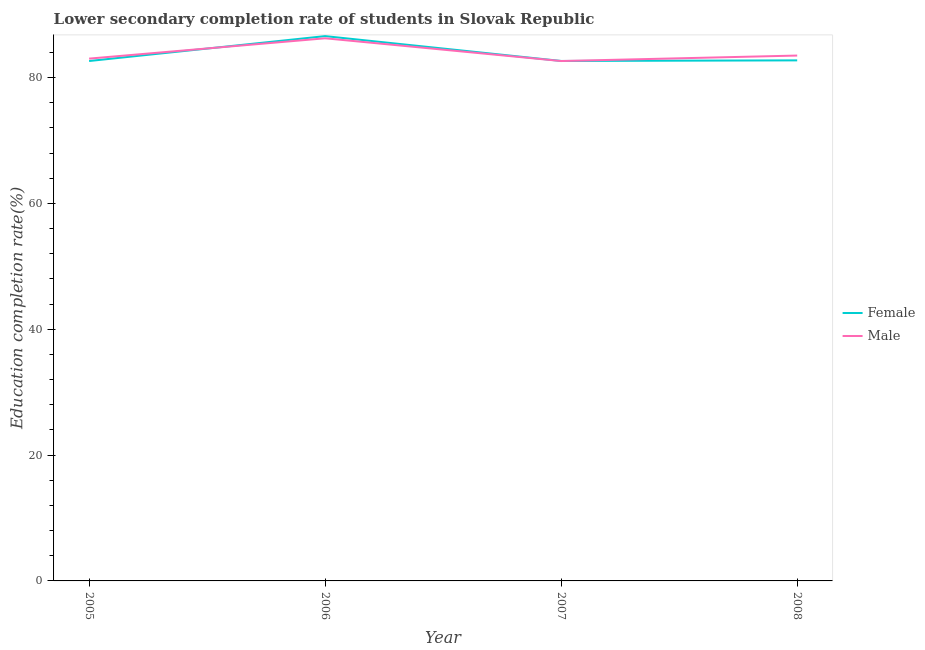How many different coloured lines are there?
Your answer should be very brief. 2. Does the line corresponding to education completion rate of female students intersect with the line corresponding to education completion rate of male students?
Ensure brevity in your answer.  Yes. Is the number of lines equal to the number of legend labels?
Keep it short and to the point. Yes. What is the education completion rate of female students in 2008?
Offer a terse response. 82.73. Across all years, what is the maximum education completion rate of female students?
Your answer should be very brief. 86.59. Across all years, what is the minimum education completion rate of male students?
Keep it short and to the point. 82.63. What is the total education completion rate of female students in the graph?
Ensure brevity in your answer.  334.58. What is the difference between the education completion rate of male students in 2007 and that in 2008?
Your answer should be very brief. -0.87. What is the difference between the education completion rate of female students in 2007 and the education completion rate of male students in 2008?
Your answer should be very brief. -0.86. What is the average education completion rate of female students per year?
Offer a terse response. 83.65. In the year 2007, what is the difference between the education completion rate of male students and education completion rate of female students?
Keep it short and to the point. -0.01. What is the ratio of the education completion rate of male students in 2005 to that in 2007?
Offer a terse response. 1. What is the difference between the highest and the second highest education completion rate of female students?
Your response must be concise. 3.86. What is the difference between the highest and the lowest education completion rate of female students?
Ensure brevity in your answer.  3.96. In how many years, is the education completion rate of male students greater than the average education completion rate of male students taken over all years?
Keep it short and to the point. 1. Is the sum of the education completion rate of female students in 2005 and 2007 greater than the maximum education completion rate of male students across all years?
Keep it short and to the point. Yes. Is the education completion rate of female students strictly greater than the education completion rate of male students over the years?
Offer a terse response. No. Are the values on the major ticks of Y-axis written in scientific E-notation?
Ensure brevity in your answer.  No. Does the graph contain any zero values?
Your response must be concise. No. How many legend labels are there?
Keep it short and to the point. 2. How are the legend labels stacked?
Provide a succinct answer. Vertical. What is the title of the graph?
Offer a very short reply. Lower secondary completion rate of students in Slovak Republic. Does "Nitrous oxide emissions" appear as one of the legend labels in the graph?
Keep it short and to the point. No. What is the label or title of the X-axis?
Offer a very short reply. Year. What is the label or title of the Y-axis?
Give a very brief answer. Education completion rate(%). What is the Education completion rate(%) in Female in 2005?
Provide a succinct answer. 82.63. What is the Education completion rate(%) of Male in 2005?
Give a very brief answer. 83.01. What is the Education completion rate(%) of Female in 2006?
Your answer should be very brief. 86.59. What is the Education completion rate(%) of Male in 2006?
Your answer should be compact. 86.24. What is the Education completion rate(%) in Female in 2007?
Your answer should be compact. 82.64. What is the Education completion rate(%) of Male in 2007?
Offer a very short reply. 82.63. What is the Education completion rate(%) of Female in 2008?
Offer a very short reply. 82.73. What is the Education completion rate(%) in Male in 2008?
Your answer should be compact. 83.5. Across all years, what is the maximum Education completion rate(%) of Female?
Give a very brief answer. 86.59. Across all years, what is the maximum Education completion rate(%) in Male?
Provide a succinct answer. 86.24. Across all years, what is the minimum Education completion rate(%) in Female?
Your answer should be very brief. 82.63. Across all years, what is the minimum Education completion rate(%) in Male?
Provide a succinct answer. 82.63. What is the total Education completion rate(%) of Female in the graph?
Provide a short and direct response. 334.58. What is the total Education completion rate(%) in Male in the graph?
Your answer should be compact. 335.37. What is the difference between the Education completion rate(%) in Female in 2005 and that in 2006?
Your answer should be very brief. -3.96. What is the difference between the Education completion rate(%) of Male in 2005 and that in 2006?
Your answer should be very brief. -3.23. What is the difference between the Education completion rate(%) in Female in 2005 and that in 2007?
Your answer should be very brief. -0.01. What is the difference between the Education completion rate(%) of Male in 2005 and that in 2007?
Keep it short and to the point. 0.38. What is the difference between the Education completion rate(%) in Female in 2005 and that in 2008?
Your answer should be compact. -0.1. What is the difference between the Education completion rate(%) in Male in 2005 and that in 2008?
Provide a succinct answer. -0.49. What is the difference between the Education completion rate(%) of Female in 2006 and that in 2007?
Ensure brevity in your answer.  3.95. What is the difference between the Education completion rate(%) in Male in 2006 and that in 2007?
Ensure brevity in your answer.  3.61. What is the difference between the Education completion rate(%) in Female in 2006 and that in 2008?
Your answer should be compact. 3.86. What is the difference between the Education completion rate(%) of Male in 2006 and that in 2008?
Offer a terse response. 2.74. What is the difference between the Education completion rate(%) of Female in 2007 and that in 2008?
Provide a short and direct response. -0.09. What is the difference between the Education completion rate(%) of Male in 2007 and that in 2008?
Offer a very short reply. -0.87. What is the difference between the Education completion rate(%) in Female in 2005 and the Education completion rate(%) in Male in 2006?
Your answer should be compact. -3.61. What is the difference between the Education completion rate(%) of Female in 2005 and the Education completion rate(%) of Male in 2007?
Your answer should be very brief. 0. What is the difference between the Education completion rate(%) of Female in 2005 and the Education completion rate(%) of Male in 2008?
Provide a succinct answer. -0.87. What is the difference between the Education completion rate(%) in Female in 2006 and the Education completion rate(%) in Male in 2007?
Provide a short and direct response. 3.96. What is the difference between the Education completion rate(%) of Female in 2006 and the Education completion rate(%) of Male in 2008?
Provide a succinct answer. 3.09. What is the difference between the Education completion rate(%) in Female in 2007 and the Education completion rate(%) in Male in 2008?
Keep it short and to the point. -0.86. What is the average Education completion rate(%) of Female per year?
Your answer should be compact. 83.65. What is the average Education completion rate(%) of Male per year?
Your response must be concise. 83.84. In the year 2005, what is the difference between the Education completion rate(%) in Female and Education completion rate(%) in Male?
Offer a terse response. -0.38. In the year 2006, what is the difference between the Education completion rate(%) in Female and Education completion rate(%) in Male?
Offer a terse response. 0.34. In the year 2007, what is the difference between the Education completion rate(%) in Female and Education completion rate(%) in Male?
Your answer should be compact. 0.01. In the year 2008, what is the difference between the Education completion rate(%) of Female and Education completion rate(%) of Male?
Make the answer very short. -0.77. What is the ratio of the Education completion rate(%) in Female in 2005 to that in 2006?
Provide a succinct answer. 0.95. What is the ratio of the Education completion rate(%) in Male in 2005 to that in 2006?
Your answer should be very brief. 0.96. What is the ratio of the Education completion rate(%) in Female in 2005 to that in 2007?
Your response must be concise. 1. What is the ratio of the Education completion rate(%) in Female in 2005 to that in 2008?
Your answer should be compact. 1. What is the ratio of the Education completion rate(%) in Male in 2005 to that in 2008?
Your response must be concise. 0.99. What is the ratio of the Education completion rate(%) in Female in 2006 to that in 2007?
Your answer should be very brief. 1.05. What is the ratio of the Education completion rate(%) in Male in 2006 to that in 2007?
Offer a very short reply. 1.04. What is the ratio of the Education completion rate(%) of Female in 2006 to that in 2008?
Ensure brevity in your answer.  1.05. What is the ratio of the Education completion rate(%) of Male in 2006 to that in 2008?
Provide a short and direct response. 1.03. What is the ratio of the Education completion rate(%) of Female in 2007 to that in 2008?
Ensure brevity in your answer.  1. What is the ratio of the Education completion rate(%) of Male in 2007 to that in 2008?
Your answer should be compact. 0.99. What is the difference between the highest and the second highest Education completion rate(%) of Female?
Offer a terse response. 3.86. What is the difference between the highest and the second highest Education completion rate(%) of Male?
Make the answer very short. 2.74. What is the difference between the highest and the lowest Education completion rate(%) in Female?
Keep it short and to the point. 3.96. What is the difference between the highest and the lowest Education completion rate(%) of Male?
Ensure brevity in your answer.  3.61. 